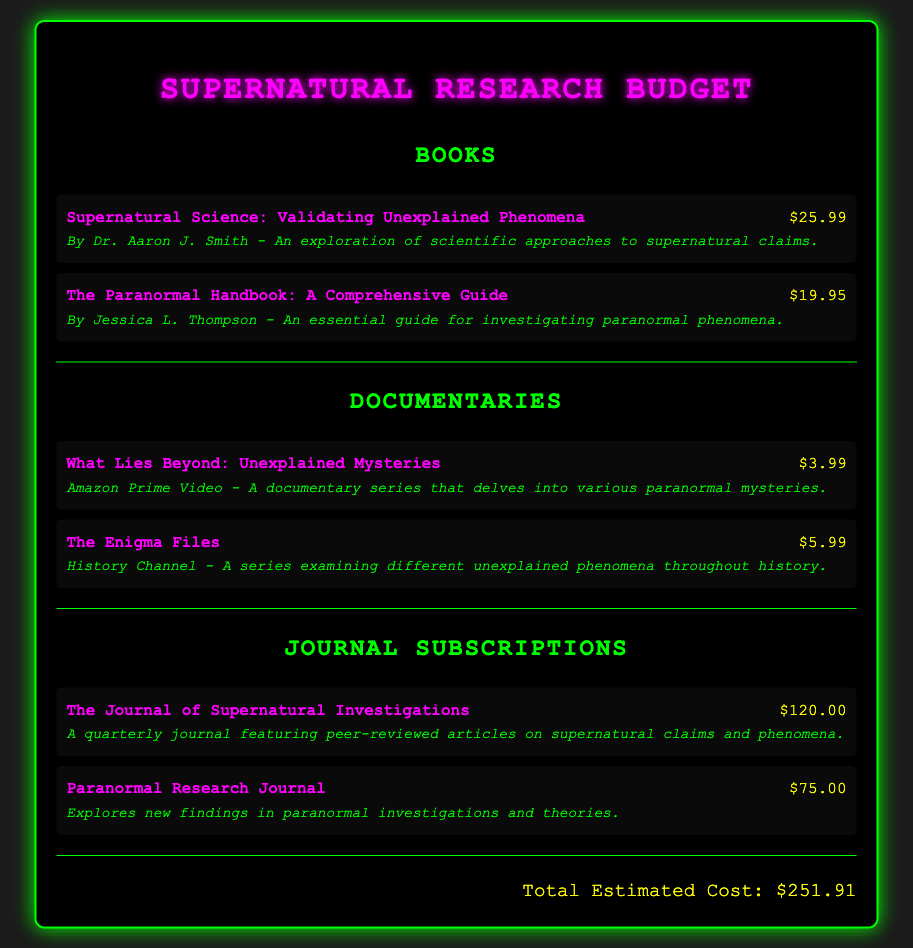what is the title of the first book listed? The first book's title is found in the "Books" section, specifically mentioned at the top.
Answer: Supernatural Science: Validating Unexplained Phenomena how much does "The Paranormal Handbook: A Comprehensive Guide" cost? The cost is indicated next to the book title in the "Books" section.
Answer: $19.95 what is the total estimated cost? The total is provided at the bottom of the document after summing up all items listed.
Answer: $251.91 which documentary costs the least? This requires comparing the costs of all documentaries listed to identify the lowest.
Answer: $3.99 how many journals are listed under Journal Subscriptions? The count of journal entries can be obtained by checking the number of items in the "Journal Subscriptions" section.
Answer: 2 what type of content does "The Journal of Supernatural Investigations" feature? The content type is described in the details under the respective journal entry in the document.
Answer: Peer-reviewed articles on supernatural claims and phenomena what is the price of the second documentary? The price of the second documentary can be found next to its title in the "Documentaries" section.
Answer: $5.99 who is the author of "Supernatural Science: Validating Unexplained Phenomena"? The author's name is provided in the details under the respective book entry.
Answer: Dr. Aaron J. Smith 